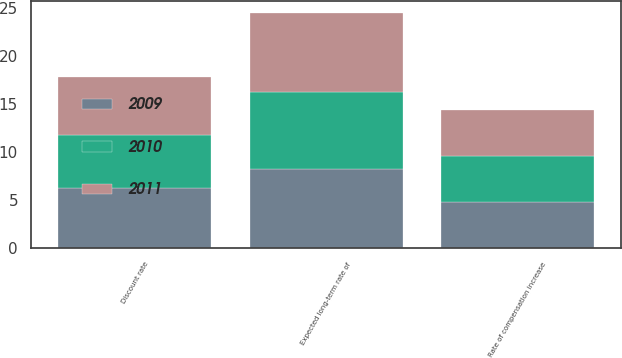Convert chart. <chart><loc_0><loc_0><loc_500><loc_500><stacked_bar_chart><ecel><fcel>Discount rate<fcel>Rate of compensation increase<fcel>Expected long-term rate of<nl><fcel>2010<fcel>5.55<fcel>4.8<fcel>8<nl><fcel>2011<fcel>6<fcel>4.8<fcel>8.25<nl><fcel>2009<fcel>6.25<fcel>4.8<fcel>8.25<nl></chart> 